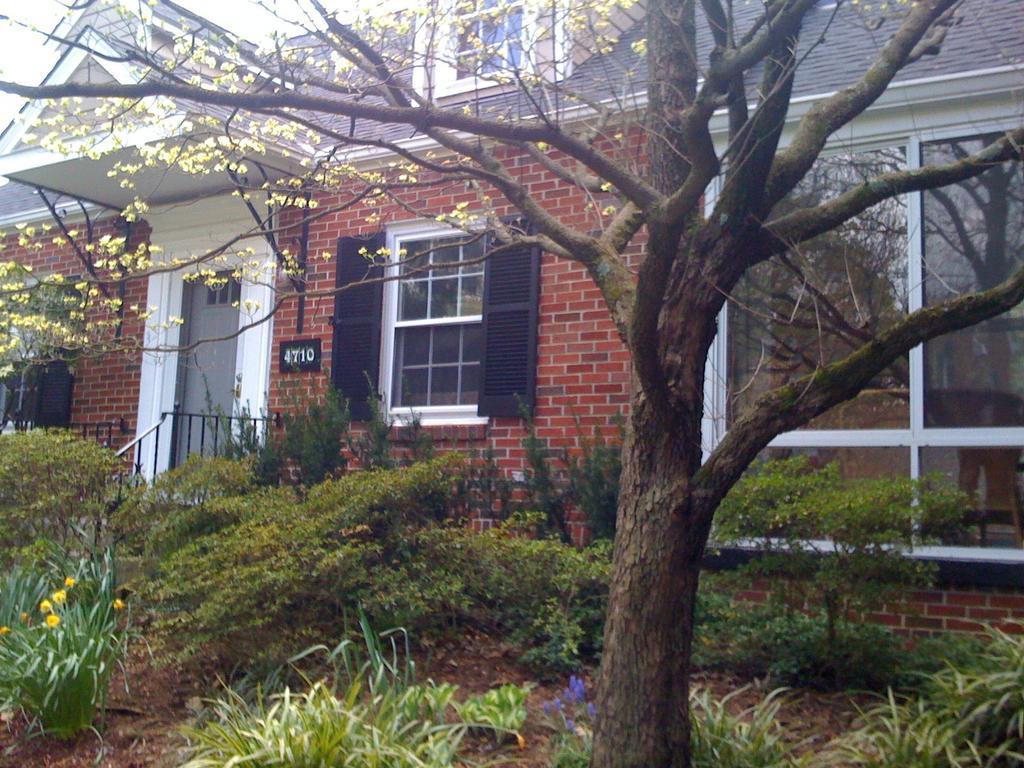Describe this image in one or two sentences. In the picture there is a house and in front of the house there are many plants and trees. 